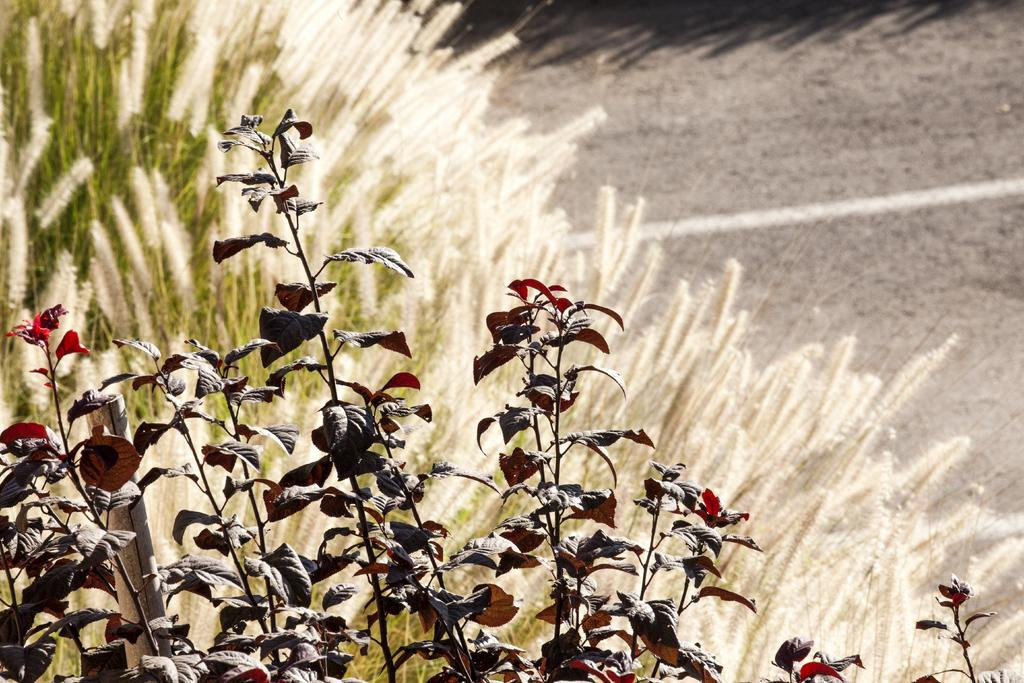What type of natural elements can be seen in the image? There are leaves and plants visible in the image. What object is made of wood in the image? There is a wooden stick in the image. What can be seen in the background of the image? There is a road visible in the background of the image. Where is the drawer located in the image? There is no drawer present in the image. What type of motion can be observed in the image? The image is still, and there is no motion visible. 